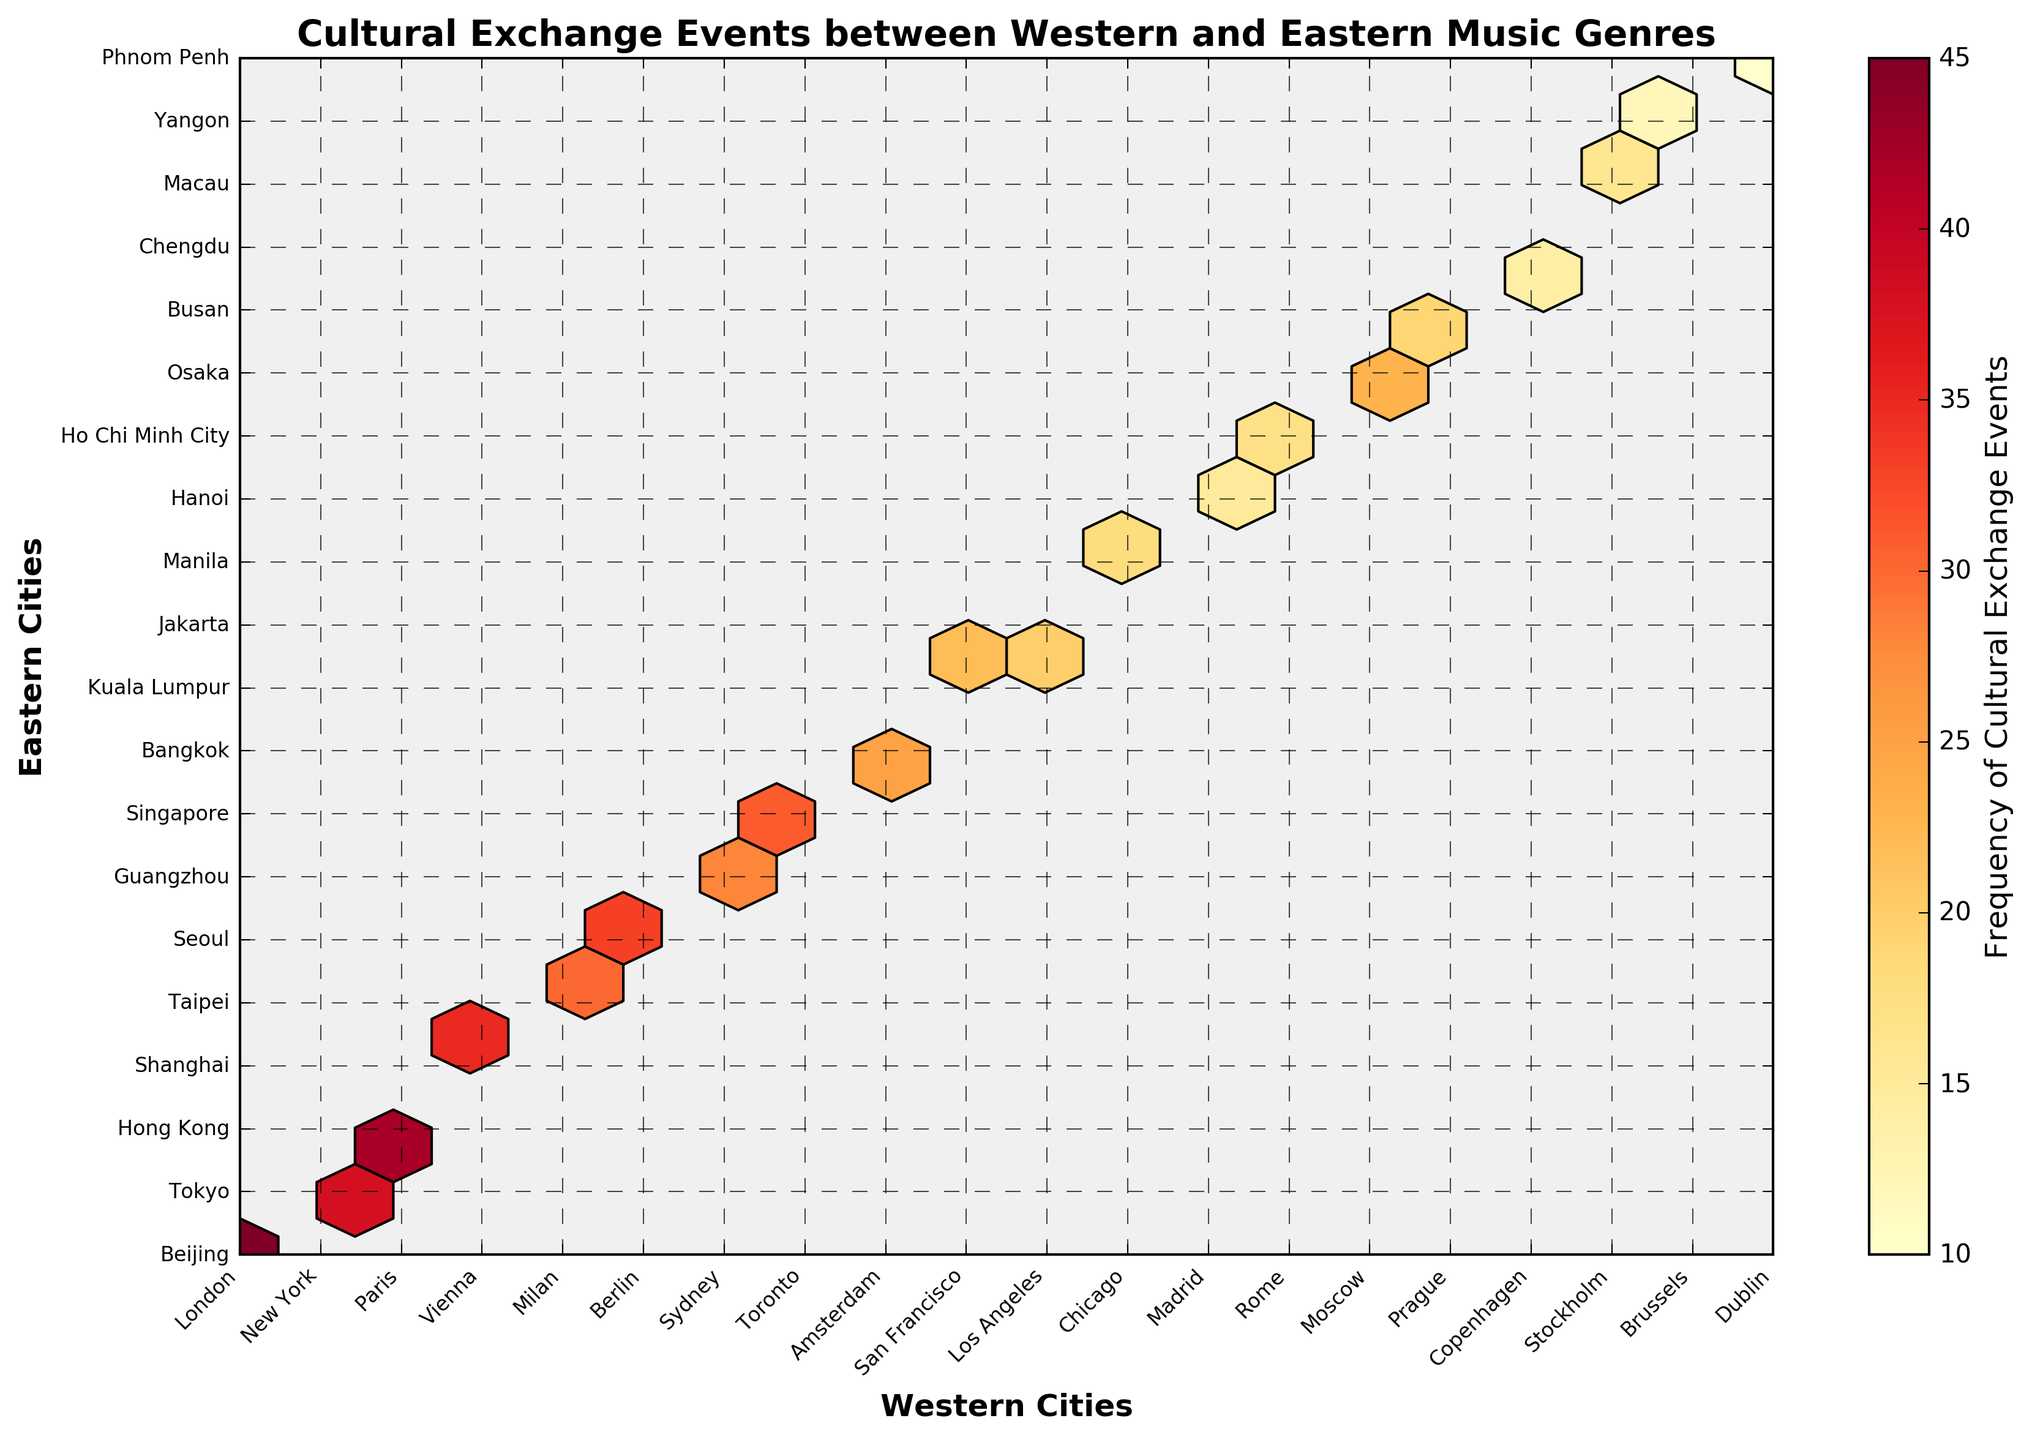What's the title of the figure? Look at the top of the figure where the title is usually located. The title is "Cultural Exchange Events between Western and Eastern Music Genres".
Answer: Cultural Exchange Events between Western and Eastern Music Genres How many hexagons are displayed in the figure? Count the number of hexagonal bins present in the hexbin plot. Each hexagon represents a bin.
Answer: 20 Which Western-Eastern city pair has the highest frequency of cultural exchange events? Check the hexagon with the highest color intensity. The color bar indicates that deeper colors represent higher frequencies.
Answer: London-Beijing What does the colorbar in the figure represent? The colorbar is usually located to the right of the plot and indicates the scale. It shows the range of frequencies of cultural exchange events.
Answer: Frequency of Cultural Exchange Events Compare the frequency of cultural exchange events between "Paris-Hong Kong" and "Rome-Ho Chi Minh City". Which pair has a higher frequency? Check the hexagons corresponding to these pairs. "Paris-Hong Kong" and "Rome-Ho Chi Minh City" have different colors representing different frequencies. The deeper color indicates a higher frequency.
Answer: Paris-Hong Kong What’s the average frequency of cultural exchange events for the city pairs with the top three highest frequencies? Identify the top three highest frequencies and calculate their average. These frequencies are represented by the deepest colors. Frequencies: London-Beijing (45), Paris-Hong Kong (42), New York-Tokyo (38). Average = (45 + 42 + 38) / 3
Answer: 41.67 Which city pair has a frequency of 30 cultural exchange events? Look at the hexagon color that matches the color indicated as 30 on the color bar. Check the corresponding city pair on the plot's x and y-axis labels.
Answer: Milan-Taipei How does the frequency of events between "Sydney-Guangzhou" compare to "Berlin-Seoul"? Check the hexagons corresponding to these pairs. Compare the colors: if "Sydney-Guangzhou" has a lighter color or shade than "Berlin-Seoul", then it has a lower frequency.
Answer: Berlin-Seoul > Sydney-Guangzhou What is the y-axis label of the figure? Read the text along the vertical axis. It indicates what the y-values represent. Here it is labeled "Eastern Cities".
Answer: Eastern Cities Do "Los Angeles-Jakarta" have more or fewer events than "Toronto-Singapore"? Identify the hexagons that correspond to these pairs and compare their colors. "Toronto-Singapore" and "Los Angeles-Jakarta" have different shades indicating their frequencies.
Answer: Fewer 